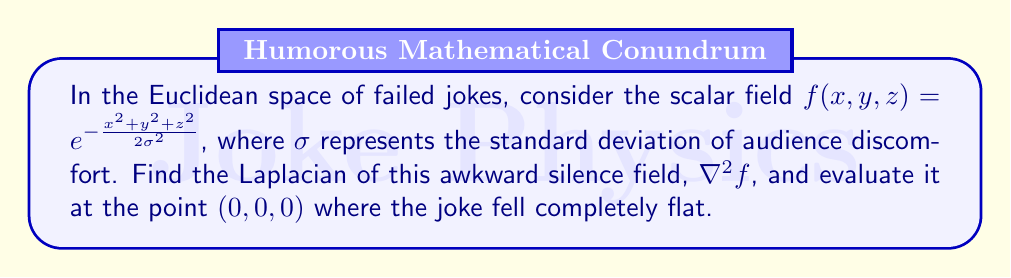Can you solve this math problem? Let's approach this step-by-step:

1) The Laplacian in 3D Cartesian coordinates is given by:

   $$\nabla^2 f = \frac{\partial^2f}{\partial x^2} + \frac{\partial^2f}{\partial y^2} + \frac{\partial^2f}{\partial z^2}$$

2) Let's calculate each second partial derivative:

   a) $\frac{\partial f}{\partial x} = -\frac{x}{\sigma^2} e^{-\frac{x^2+y^2+z^2}{2\sigma^2}}$
   
      $\frac{\partial^2 f}{\partial x^2} = (-\frac{1}{\sigma^2} + \frac{x^2}{\sigma^4}) e^{-\frac{x^2+y^2+z^2}{2\sigma^2}}$

   b) $\frac{\partial f}{\partial y} = -\frac{y}{\sigma^2} e^{-\frac{x^2+y^2+z^2}{2\sigma^2}}$
   
      $\frac{\partial^2 f}{\partial y^2} = (-\frac{1}{\sigma^2} + \frac{y^2}{\sigma^4}) e^{-\frac{x^2+y^2+z^2}{2\sigma^2}}$

   c) $\frac{\partial f}{\partial z} = -\frac{z}{\sigma^2} e^{-\frac{x^2+y^2+z^2}{2\sigma^2}}$
   
      $\frac{\partial^2 f}{\partial z^2} = (-\frac{1}{\sigma^2} + \frac{z^2}{\sigma^4}) e^{-\frac{x^2+y^2+z^2}{2\sigma^2}}$

3) Now, let's sum these up to get the Laplacian:

   $$\nabla^2 f = (-\frac{3}{\sigma^2} + \frac{x^2+y^2+z^2}{\sigma^4}) e^{-\frac{x^2+y^2+z^2}{2\sigma^2}}$$

4) To evaluate at the point (0,0,0) where the joke fell completely flat:

   $$\nabla^2 f|_{(0,0,0)} = -\frac{3}{\sigma^2} e^{0} = -\frac{3}{\sigma^2}$$

This negative value indicates that the awkwardness is at a local maximum at the point of the failed joke, which makes sense in the context of our comedian's predicament.
Answer: $-\frac{3}{\sigma^2}$ 